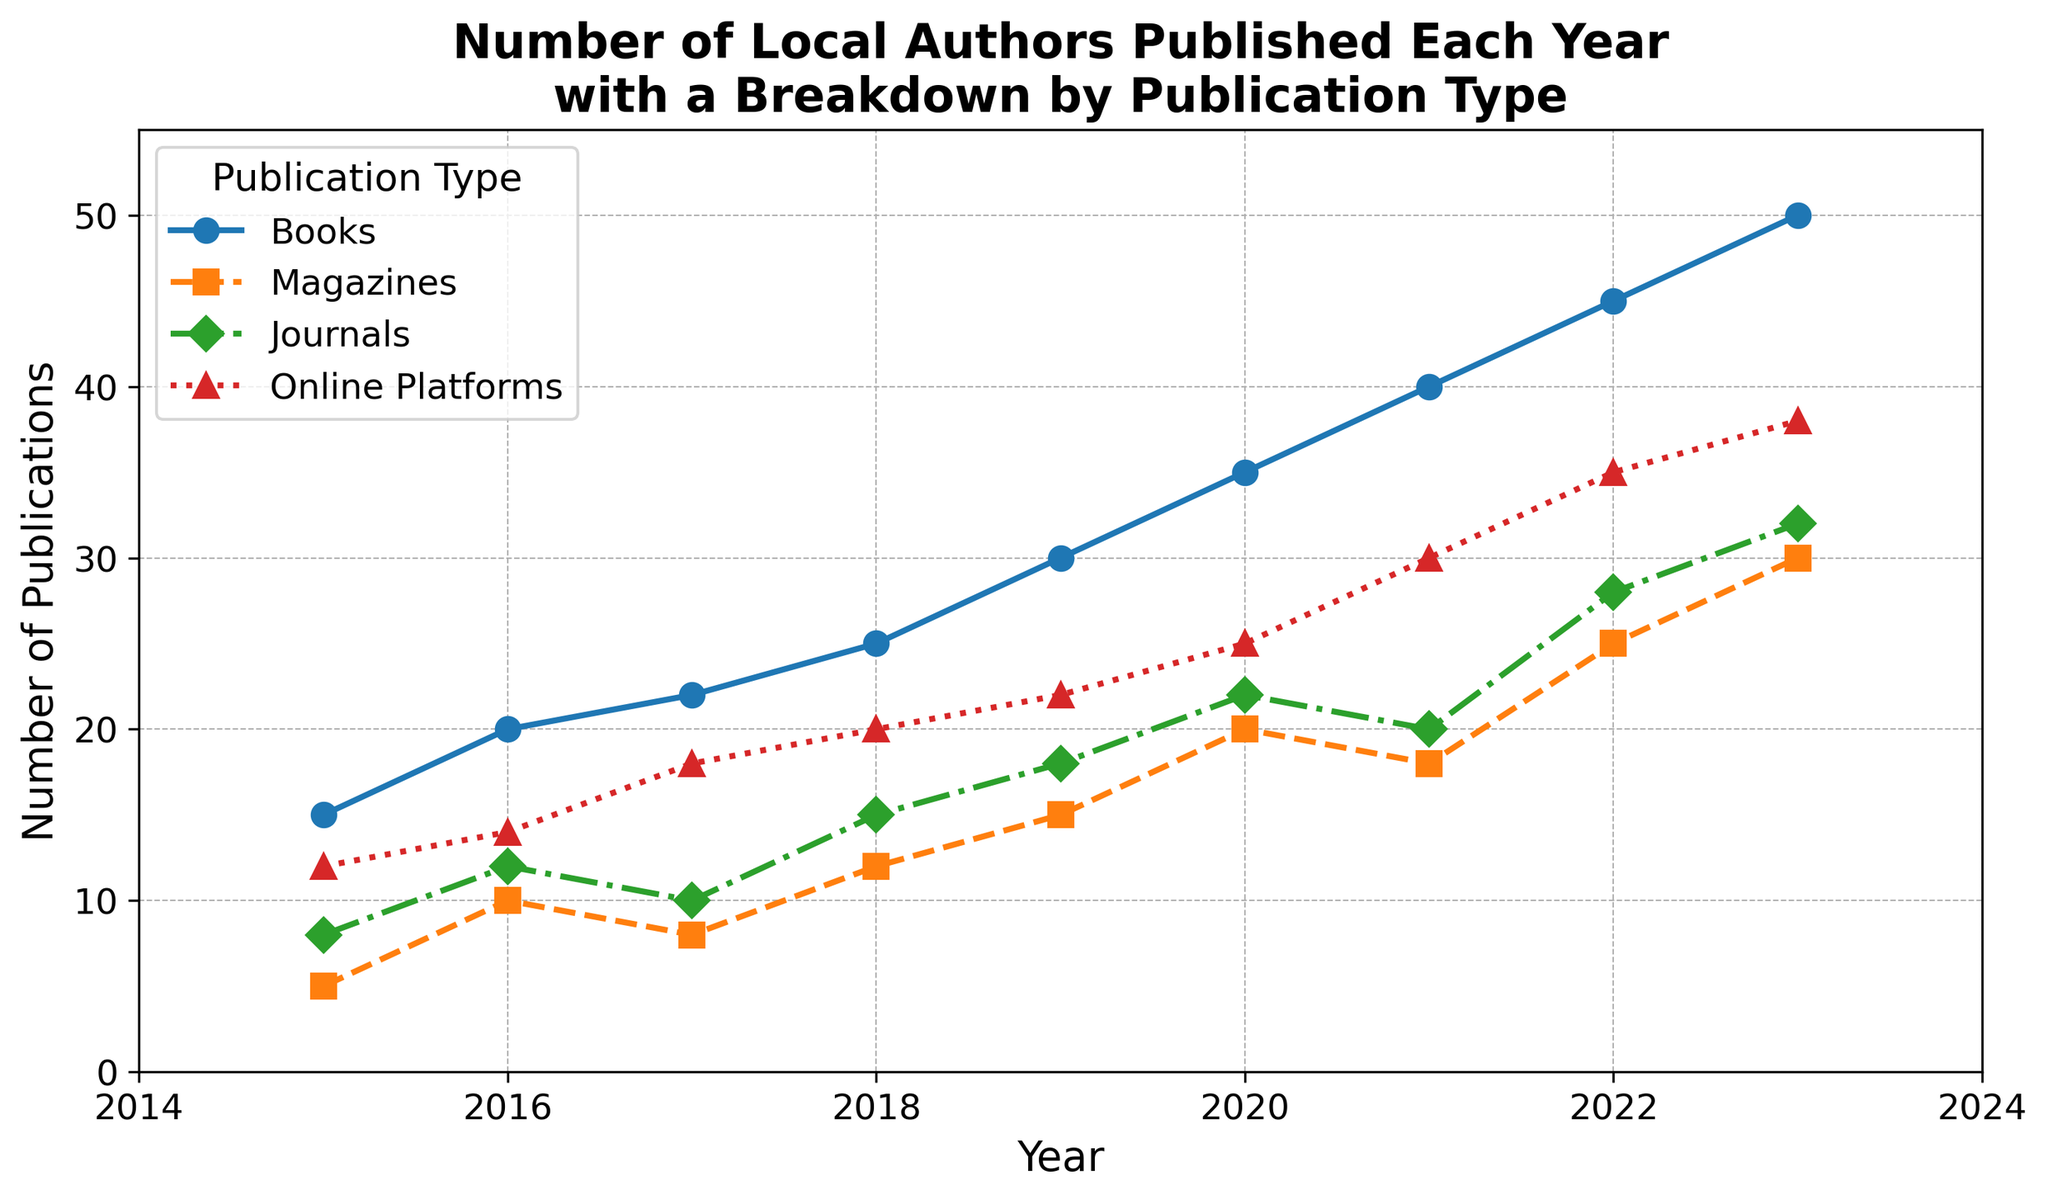What was the total number of publications in 2020 across all types? Sum the numbers of Books, Magazines, Journals, and Online Platforms for 2020: 35 (Books) + 20 (Magazines) + 22 (Journals) + 25 (Online Platforms) = 102
Answer: 102 Which year had the highest number of Journal publications? Observe the data points for Journals across all years to find the highest value. In 2023, the number of Journal publications was 32, which is the highest.
Answer: 2023 In which year did the number of Magazine publications decrease compared to the previous year? Look at the trend of Magazines from year to year. In 2021, the number of Magazine publications decreased to 18 from 20 in 2020.
Answer: 2021 How did the number of Online Platform publications in 2023 compare to those in 2018? Subtract the number of Online Platform publications in 2018 from those in 2023: 38 (2023) - 20 (2018) = 18. Therefore, there were 18 more Online Platform publications in 2023 compared to 2018.
Answer: 18 more What is the average number of Books published per year from 2015 to 2023? Sum the number of Books published each year from 2015 to 2023 and divide by the number of years (9): (15 + 20 + 22 + 25 + 30 + 35 + 40 + 45 + 50) / 9 = 282 / 9 = 31.33
Answer: 31.33 Which publication type consistently showed an increasing trend from 2015 to 2023? Examine the trends of all publication types from 2015 to 2023. Books and Online Platforms show a consistent increase every year.
Answer: Books and Online Platforms By how much did the total number of publications increase from 2019 to 2023? Calculate the total number of publications for 2019 and 2023, then find the difference: 2019 total = 30 (Books) + 15 (Magazines) + 18 (Journals) + 22 (Online Platforms) = 85; 2023 total = 50 (Books) + 30 (Magazines) + 32 (Journals) + 38 (Online Platforms) = 150; Difference = 150 - 85 = 65
Answer: 65 Was there any year where the number of Online Platform publications was equal to the number of Journal publications? Compare the number of Journal and Online Platform publications each year from 2015 to 2023. There is no year where the two numbers are equal.
Answer: No Which publication type saw the most substantial increase between 2015 and 2023? Identify the change in the number of publications for each type between 2015 and 2023 and find the largest change: Books increased by 35 (50 - 15), Magazines increased by 25 (30 - 5), Journals increased by 24 (32 - 8), and Online Platforms increased by 26 (38 - 12). Therefore, Books saw the most substantial increase.
Answer: Books 